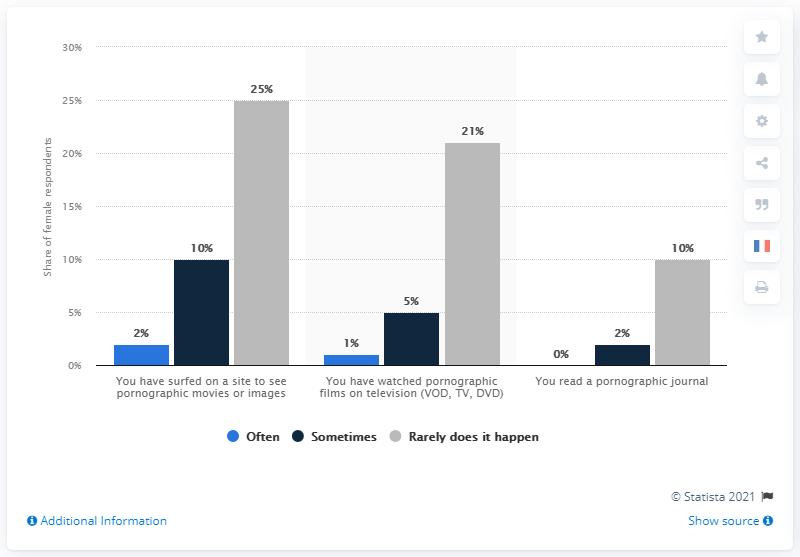Highlight a few significant elements in this photo. The difference between the highest and lowest values of the gray bar is 15. None of the female respondents often read a pornographic journal, according to the survey results. 